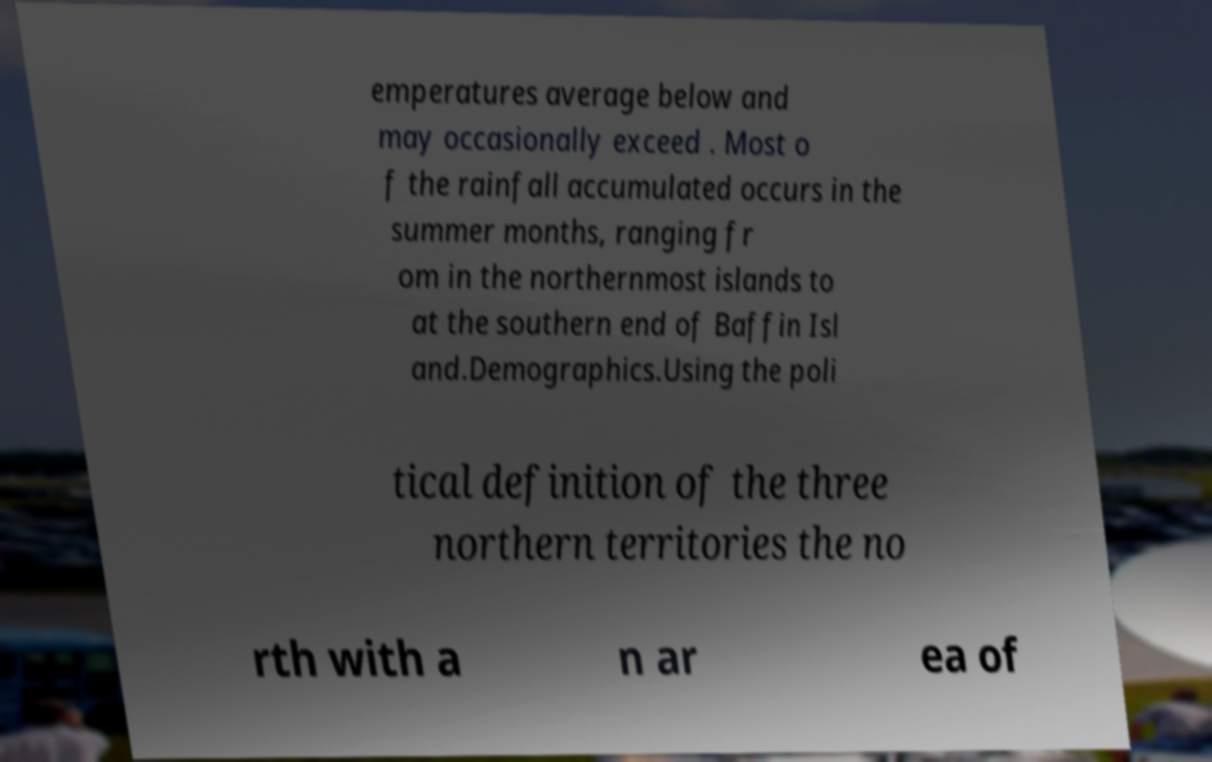Please read and relay the text visible in this image. What does it say? emperatures average below and may occasionally exceed . Most o f the rainfall accumulated occurs in the summer months, ranging fr om in the northernmost islands to at the southern end of Baffin Isl and.Demographics.Using the poli tical definition of the three northern territories the no rth with a n ar ea of 